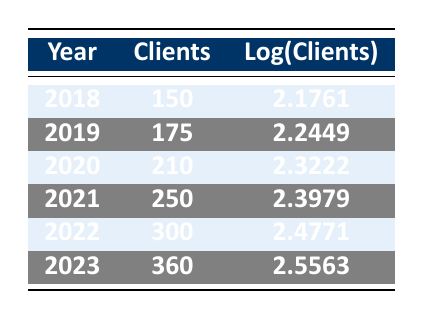What was the number of clients in 2020? According to the table, under the year 2020, the number of clients is listed as 210.
Answer: 210 What is the logarithm of the number of clients in 2022? From the table, the logarithmic value of clients for the year 2022 is given as 2.4771.
Answer: 2.4771 Which year had the highest number of clients, and how many clients were there? The year 2023 has the highest number of clients at 360, as seen at the bottom of the table.
Answer: 2023, 360 What is the difference in the number of clients between 2018 and 2023? From the table, the number of clients in 2018 is 150 and in 2023 is 360. The difference is 360 - 150 = 210.
Answer: 210 Is the number of clients in 2019 greater than the average number of clients over all the years listed? To find the average, sum the clients from 2018 to 2023: (150 + 175 + 210 + 250 + 300 + 360) = 1445, and divide by 6, which gives an average of 241.67. Since 175 (2019's clients) is less than 241.67, the answer is no.
Answer: No What is the rate of growth in the number of clients from 2021 to 2022? The number of clients in 2021 is 250 and in 2022 is 300. The growth rate can be calculated as (300 - 250) / 250 = 0.2, which means a 20% growth.
Answer: 20% Which year saw an increase of at least 50 clients compared to the previous year? By checking the increases for each year: 2019 (175 - 150 = 25), 2020 (210 - 175 = 35), 2021 (250 - 210 = 40), 2022 (300 - 250 = 50), and 2023 (360 - 300 = 60), we see that both 2022 and 2023 have increases of 50 or more.
Answer: 2022, 2023 What is the median number of clients from 2018 to 2023? The number of clients are: 150, 175, 210, 250, 300, 360. Arranging these gives: 150, 175, 210, 250, 300, 360. The median is the average of the two middle numbers (210 and 250), resulting in (210 + 250) / 2 = 220.
Answer: 220 Did the number of clients increase every year? By examining the data, we see that each year the number of clients increased compared to the previous year: 150 to 175, 175 to 210, 210 to 250, 250 to 300, and 300 to 360. Therefore, the answer is yes.
Answer: Yes 